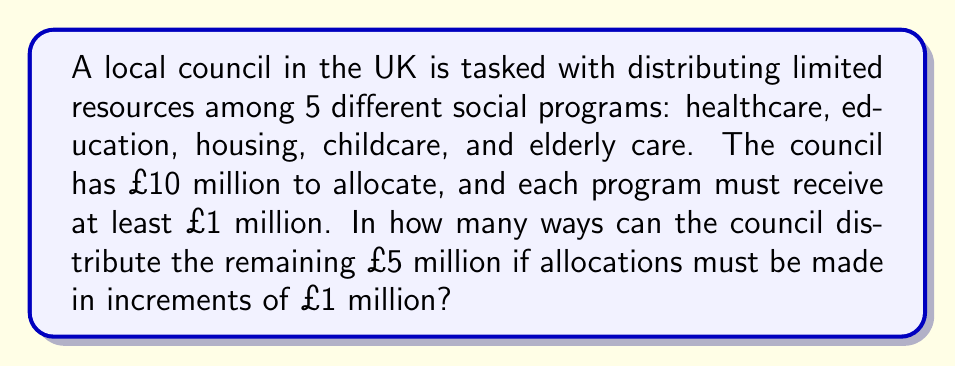Teach me how to tackle this problem. This problem can be solved using the concept of combinations with repetition, also known as stars and bars.

1) We start with £10 million, and each of the 5 programs must receive at least £1 million. This leaves £5 million to be distributed.

2) We can think of this as distributing 5 indistinguishable objects (£1 million units) among 5 distinct programs.

3) The formula for combinations with repetition is:

   $$\binom{n+r-1}{r}$$

   where $n$ is the number of distinct programs and $r$ is the number of indistinguishable objects.

4) In this case, $n = 5$ (programs) and $r = 5$ (remaining £1 million units).

5) Plugging these values into the formula:

   $$\binom{5+5-1}{5} = \binom{9}{5}$$

6) We can calculate this using the combination formula:

   $$\binom{9}{5} = \frac{9!}{5!(9-5)!} = \frac{9!}{5!4!}$$

7) Expanding this:

   $$\frac{9 * 8 * 7 * 6 * 5!}{5! * 4 * 3 * 2 * 1} = \frac{3024}{24} = 126$$

Therefore, there are 126 ways to distribute the remaining £5 million among the 5 social programs.
Answer: 126 ways 